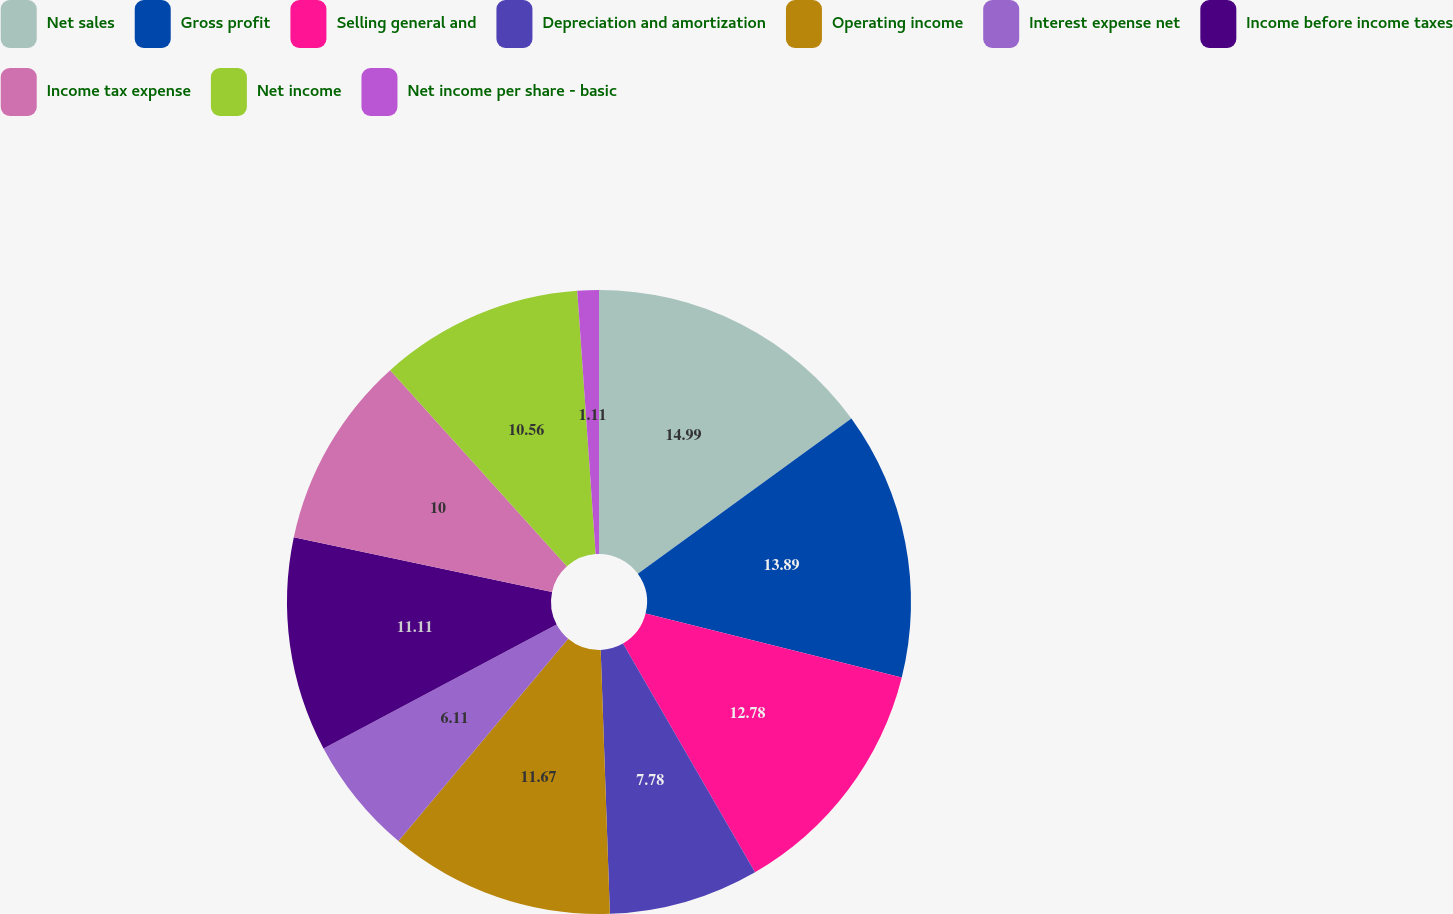<chart> <loc_0><loc_0><loc_500><loc_500><pie_chart><fcel>Net sales<fcel>Gross profit<fcel>Selling general and<fcel>Depreciation and amortization<fcel>Operating income<fcel>Interest expense net<fcel>Income before income taxes<fcel>Income tax expense<fcel>Net income<fcel>Net income per share - basic<nl><fcel>15.0%<fcel>13.89%<fcel>12.78%<fcel>7.78%<fcel>11.67%<fcel>6.11%<fcel>11.11%<fcel>10.0%<fcel>10.56%<fcel>1.11%<nl></chart> 